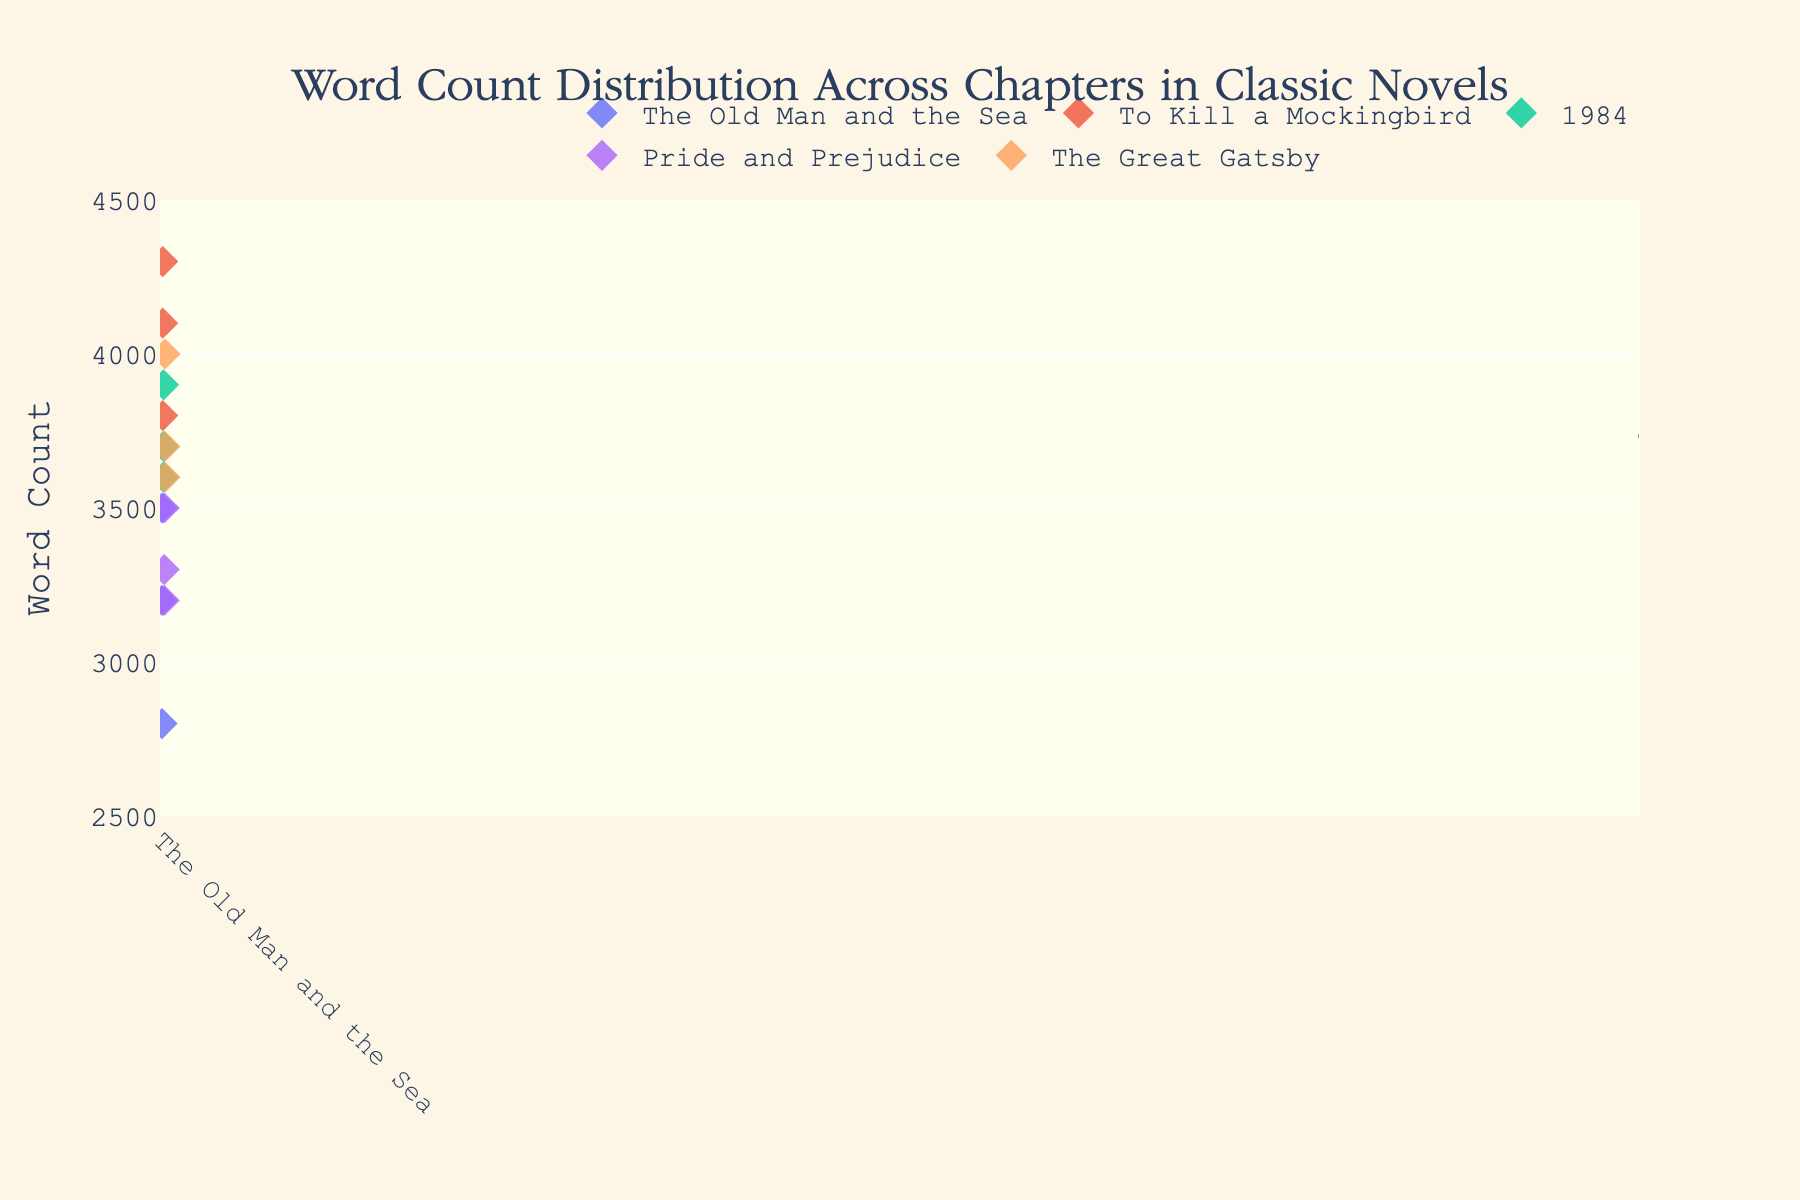What is the title of the figure? The title is written at the top of the figure and serves as a brief description of what the plot represents.
Answer: Word Count Distribution Across Chapters in Classic Novels What are the labels on the x-axis and y-axis? The labels on the axes help to identify what each axis represents in the plot. The x-axis should represent the novels, and the y-axis should indicate the word count.
Answer: The x-axis has novels, and the y-axis is labeled "Word Count" Which novel has the highest average word count across chapters? Each novel has a dashed line representing its average word count. Comparing these lines across novels identifies the highest one.
Answer: To Kill a Mockingbird Which chapter in "The Great Gatsby" has the highest word count? By locating "The Great Gatsby" on the x-axis and comparing the points on the y-axis within its group, we can determine which chapter has the highest word count.
Answer: Chapter 2 What can you say about the distribution of word counts in "1984"? Observing the points for "1984" on the plot, we can note how close or spread out they appear in relation to the y-axis values.
Answer: The word counts are fairly close in range, between 3600 and 3900 Which novel shows the greatest variation in chapter word counts? By observing the spread of data points for each novel, the one with the broadest spread indicates the greatest variation.
Answer: The Old Man and the Sea How does the word count of Chapter 1 in "To Kill a Mockingbird" compare to Chapter 1 in "Pride and Prejudice"? Locate Chapter 1 points for both novels and compare their positions on the y-axis to determine which is higher or lower.
Answer: Chapter 1 in "To Kill a Mockingbird" has a higher word count Is there any novel with a consistent word count across all chapters? Look for a novel whose points are very close to each other along the y-axis. Consistent positions imply minimal variation.
Answer: No, all novels show some variation What is the mean word count of chapters in "Pride and Prejudice"? Find the dashed line that represents the mean for "Pride and Prejudice" and read its position on the y-axis.
Answer: Approximately 3333 Which novel's chapters have the smallest average word count? Observing the dashed lines representing means, identify the novel with the lowest average word count.
Answer: The Old Man and the Sea 